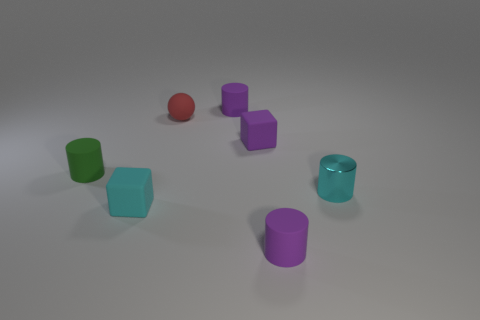What textures are visible on the surfaces in the image, and how do they differ? The objects in the image exhibit two main types of textures. The first texture is a matte finish, seen on the green cylinder, red sphere, the cubes, and purple cylinders, all of which diffuse light, giving them a soft appearance. In contrast, the teal cylinder has a glossy texture, reflected by the way it shines and reflects the light distinctly, making it seem smoother and more reflective than the others. How does the lighting affect these textures? The lighting plays a crucial role in accentuating the differing textures. Objects with a matte finish absorb the light, which mutes their appearance and obscures fine details. On the other hand, the glossy teal cylinder reflects the light, highlighting its smoothness and the environment's reflections on its surface, thus providing a sense of depth to its shape and form. 